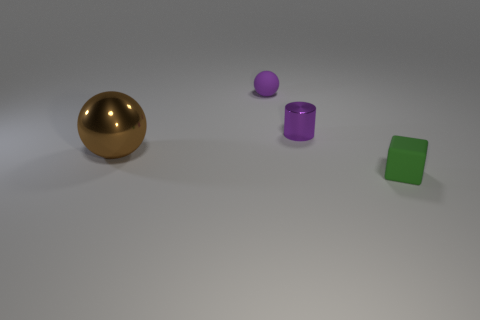What material is the object that is in front of the sphere in front of the sphere that is right of the large object?
Offer a very short reply. Rubber. How many gray objects are either big matte objects or big objects?
Your response must be concise. 0. There is a ball that is on the left side of the purple thing that is on the left side of the metallic object that is right of the big sphere; what size is it?
Ensure brevity in your answer.  Large. What size is the other thing that is the same shape as the tiny purple matte thing?
Offer a very short reply. Large. What number of tiny objects are either balls or green matte cubes?
Offer a terse response. 2. Are the tiny purple thing on the right side of the small matte sphere and the object that is in front of the brown sphere made of the same material?
Your response must be concise. No. What is the material of the tiny purple object that is on the right side of the tiny ball?
Make the answer very short. Metal. What number of shiny things are brown spheres or large blue blocks?
Provide a succinct answer. 1. The ball that is to the left of the matte thing that is behind the tiny green matte block is what color?
Ensure brevity in your answer.  Brown. Is the cylinder made of the same material as the object in front of the brown shiny thing?
Offer a terse response. No. 